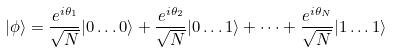<formula> <loc_0><loc_0><loc_500><loc_500>| \phi \rangle = \frac { e ^ { i \theta _ { 1 } } } { \sqrt { N } } | 0 \dots 0 \rangle + \frac { e ^ { i \theta _ { 2 } } } { \sqrt { N } } | 0 \dots 1 \rangle + \dots + \frac { e ^ { i \theta _ { N } } } { \sqrt { N } } | 1 \dots 1 \rangle</formula> 